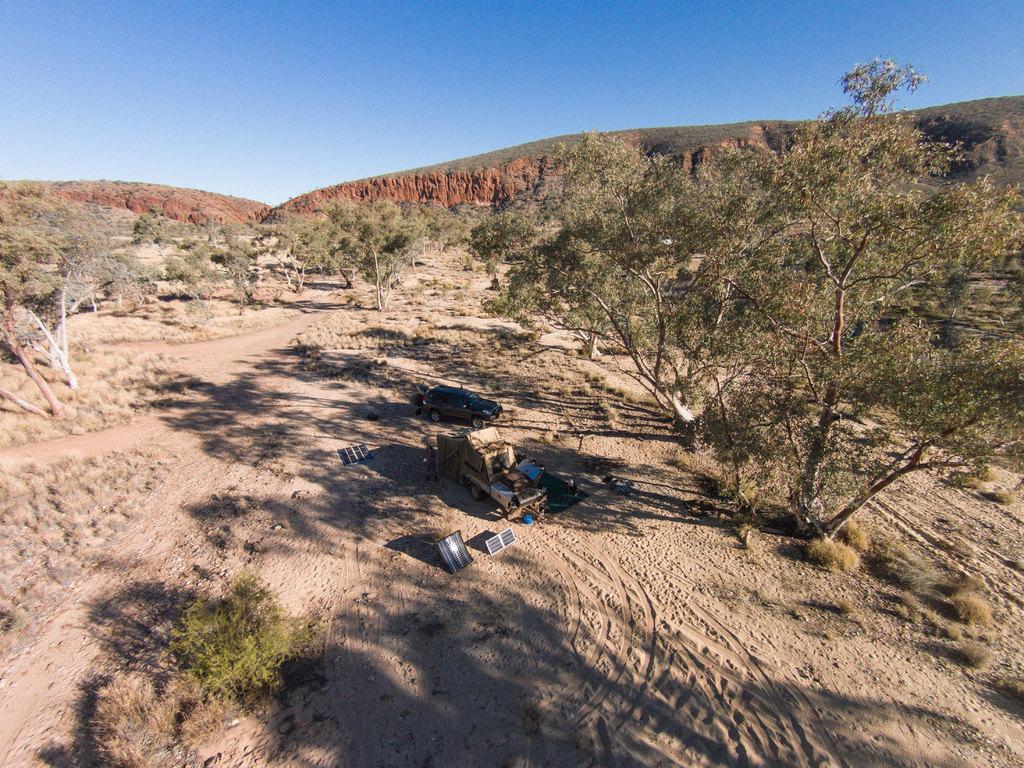Please provide a concise description of this image. At the center of the image there are some objects placed on the ground and one car is Parked. In the surroundings of the objects they are trees. In the background of the image there is a mountain and sky. 